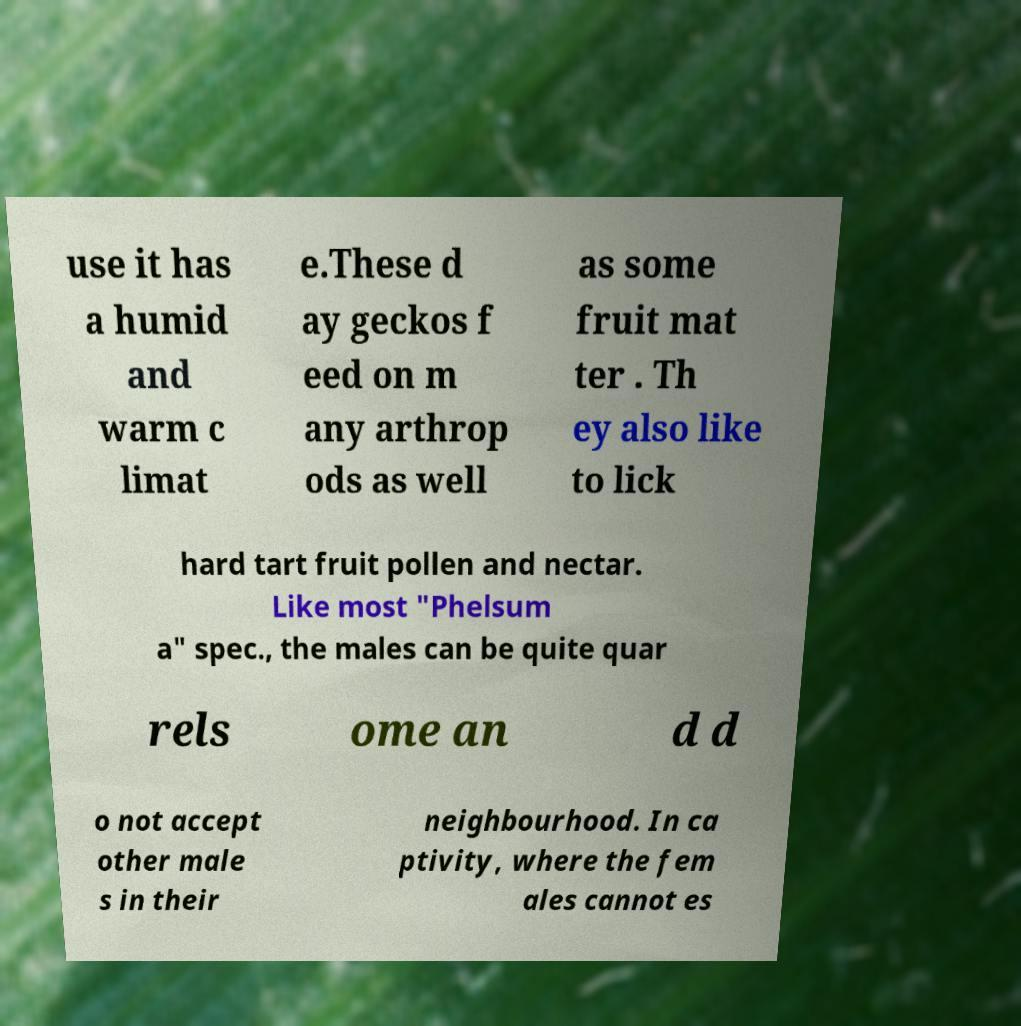I need the written content from this picture converted into text. Can you do that? use it has a humid and warm c limat e.These d ay geckos f eed on m any arthrop ods as well as some fruit mat ter . Th ey also like to lick hard tart fruit pollen and nectar. Like most "Phelsum a" spec., the males can be quite quar rels ome an d d o not accept other male s in their neighbourhood. In ca ptivity, where the fem ales cannot es 